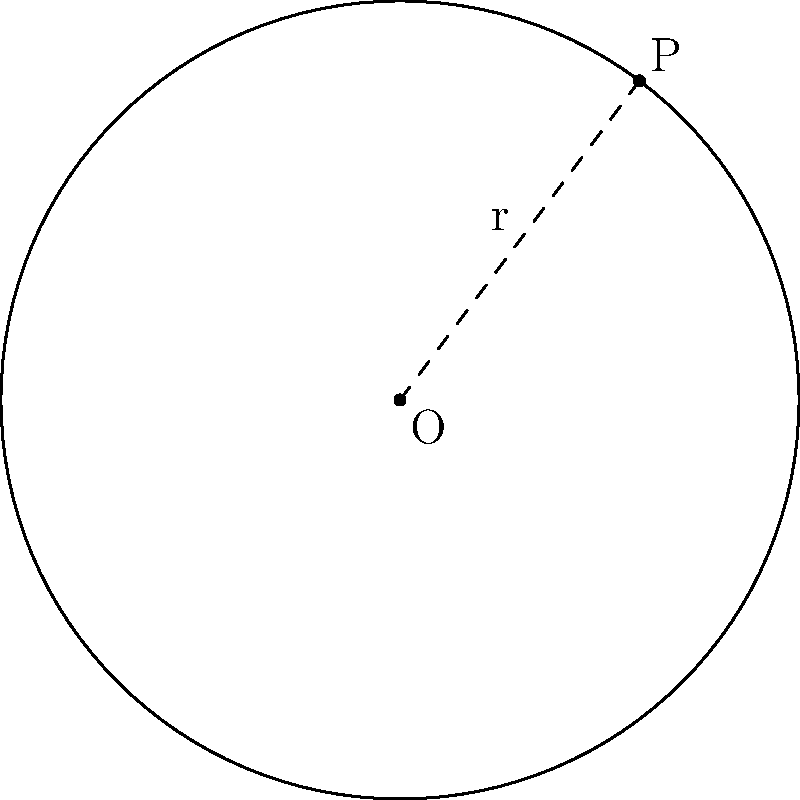In a study on the spatial distribution of religious centers, a sociologist plots the locations on a coordinate system. A circular region of influence is identified with its center at (2,3) and passing through the point (5,7). Determine the equation of this circle, which represents the boundary of the region's influence. To find the equation of the circle, we'll follow these steps:

1) The general equation of a circle is $$(x-h)^2 + (y-k)^2 = r^2$$
   where (h,k) is the center and r is the radius.

2) We're given the center O(2,3), so h=2 and k=3.

3) To find r, we need to calculate the distance between the center O(2,3) and the point P(5,7) on the circumference:

   $$r = \sqrt{(x_P-x_O)^2 + (y_P-y_O)^2}$$
   $$r = \sqrt{(5-2)^2 + (7-3)^2}$$
   $$r = \sqrt{3^2 + 4^2}$$
   $$r = \sqrt{9 + 16} = \sqrt{25} = 5$$

4) Now we can substitute these values into the general equation:

   $$(x-2)^2 + (y-3)^2 = 5^2$$

5) Simplify:

   $$(x-2)^2 + (y-3)^2 = 25$$

This is the equation of the circle representing the boundary of the region's influence.
Answer: $(x-2)^2 + (y-3)^2 = 25$ 